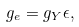<formula> <loc_0><loc_0><loc_500><loc_500>g _ { e } = g _ { Y } \epsilon ,</formula> 